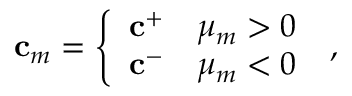<formula> <loc_0><loc_0><loc_500><loc_500>c _ { m } = \left \{ \begin{array} { l l } { c ^ { + } } & { \mu _ { m } > 0 } \\ { c ^ { - } } & { \mu _ { m } < 0 } \end{array} \, ,</formula> 